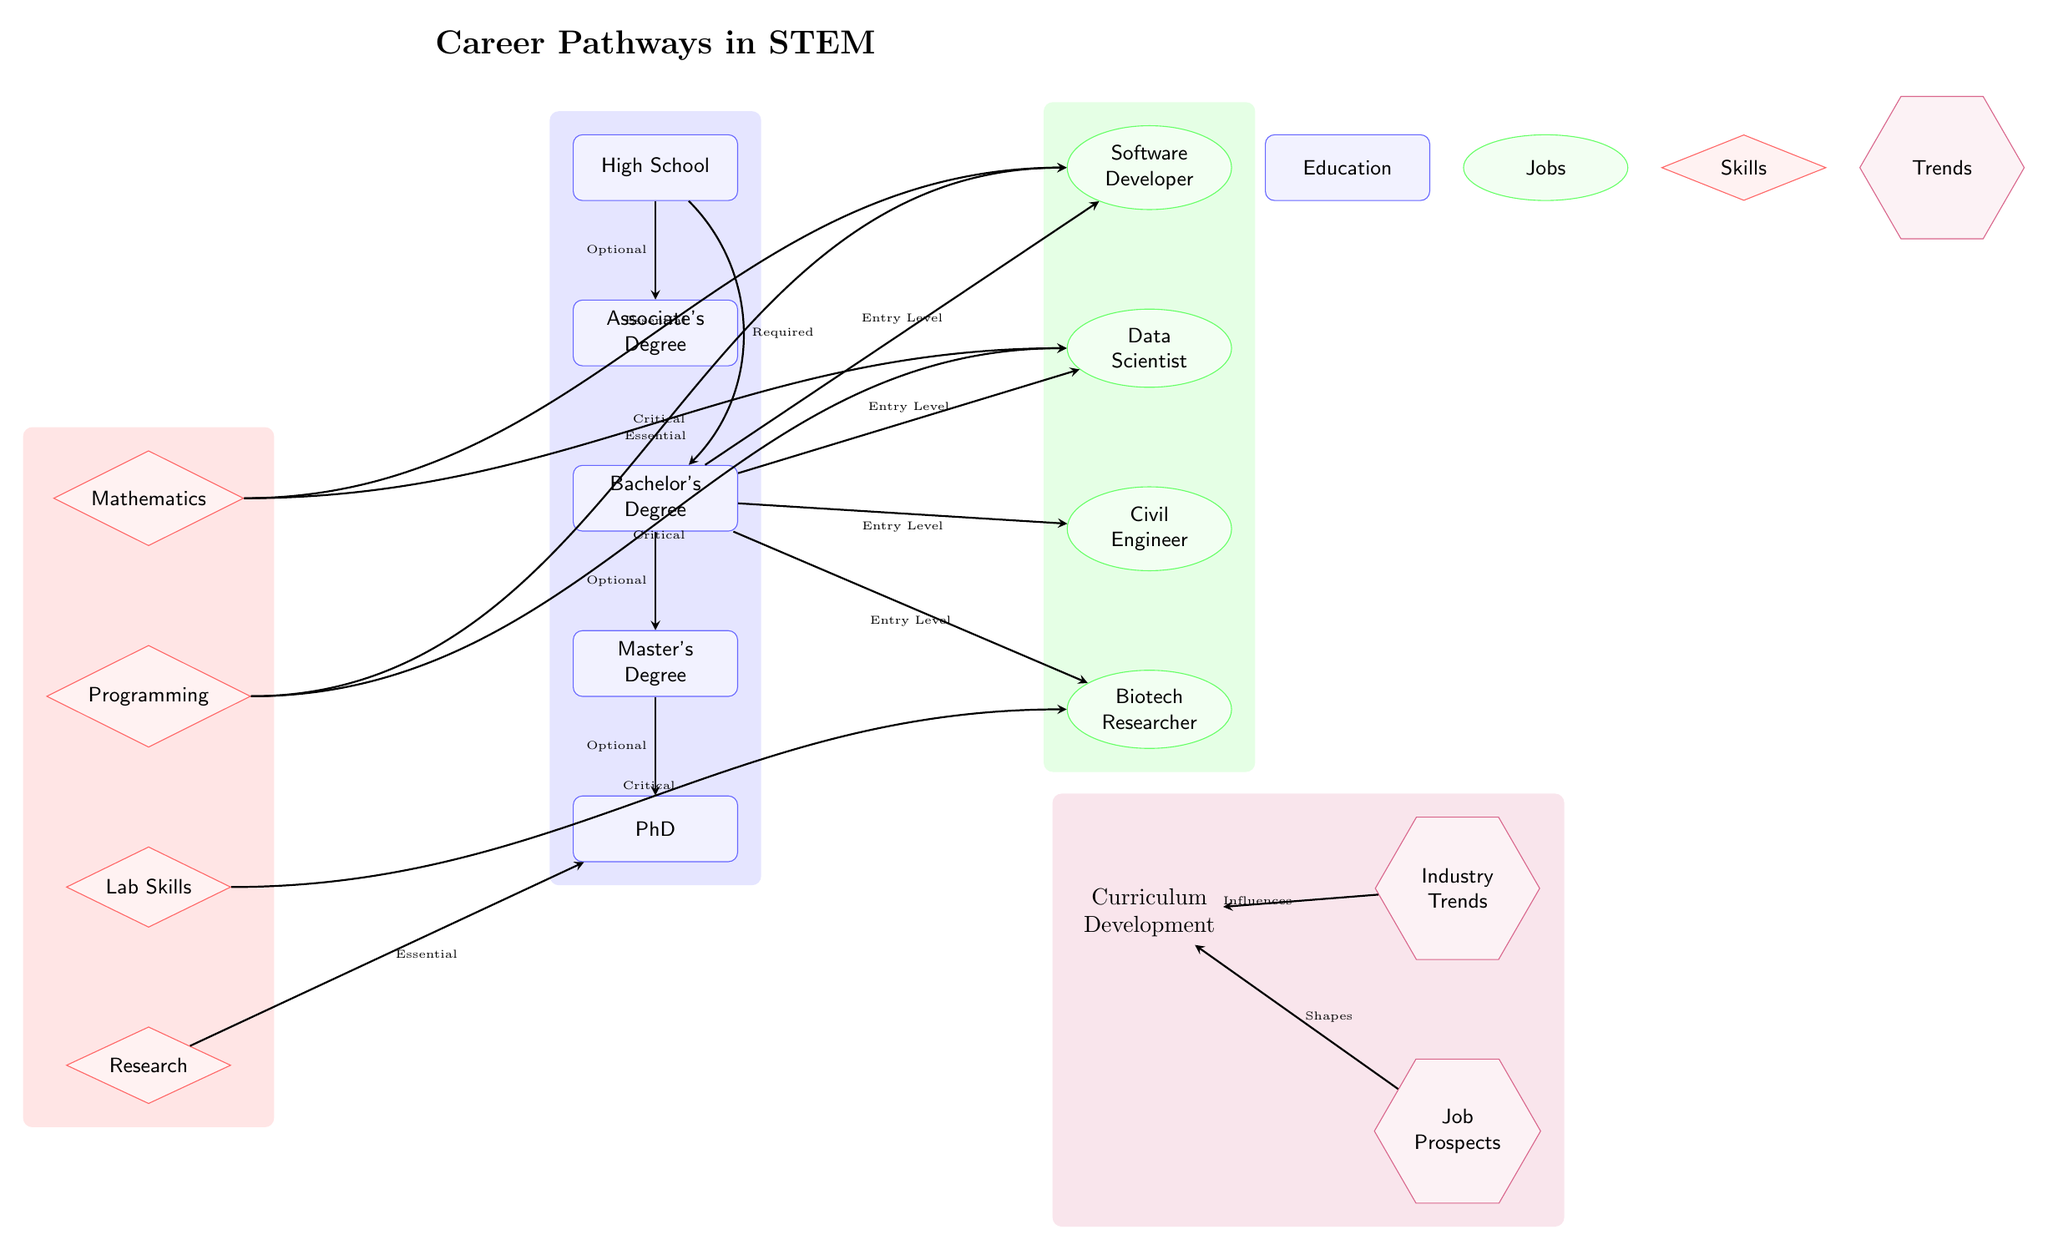What is the highest level of education shown? The diagram lists a series of educational nodes starting from High School to PhD. The highest level is represented by the PhD node.
Answer: PhD How many job nodes are depicted in the diagram? The diagram displays four job nodes: Software Developer, Data Scientist, Civil Engineer, and Biotech Researcher. Counting these nodes gives a total of four.
Answer: 4 Which job is connected to the skill "Programming"? The skill "Programming" node has arrows pointing towards both the Software Developer and Data Scientist job nodes, indicating both jobs require this skill.
Answer: Software Developer, Data Scientist What is the relationship between Associate's Degree and Bachelor's Degree? The diagram shows an arrow from Associate's Degree to Bachelor's Degree indicating that the Associate's Degree is optional to obtain a Bachelor's Degree, which provides a pathway for further education.
Answer: Optional Which skill is labeled as "Critical" for both Software Developer and Data Scientist? The skill node "Programming" has connections labeled "Critical" towards both Software Developer and Data Scientist, showing the importance of this skill in those professions.
Answer: Programming Which trends influence Curriculum Development? The diagram shows arrows from both Industry Trends and Job Prospects nodes pointing to Curriculum Development, indicating that these trends shape and influence how curriculum is developed.
Answer: Industry Trends, Job Prospects What do you call the connections between educational levels? The diagram illustrates the connections between the educational levels with arrows labeled according to the requirement (e.g., Required, Optional). Collectively, these connections outline the educational pathways.
Answer: Educational pathways What job is typically considered an entry-level position? According to the diagram, all job nodes (Software Developer, Data Scientist, Civil Engineer, Biotech Researcher) are labeled as "Entry Level," meaning they are suitable for graduates with a Bachelor's Degree.
Answer: Software Developer, Data Scientist, Civil Engineer, Biotech Researcher How many essential skills are required for the job of a Biotech Researcher? The diagram indicates that the Biotech Researcher job requires only one essential skill labeled "Lab Skills" along with having a Master's or PhD.
Answer: 1 